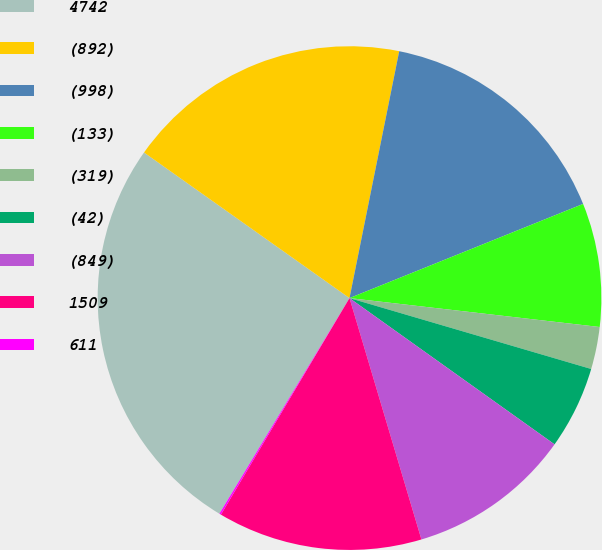Convert chart. <chart><loc_0><loc_0><loc_500><loc_500><pie_chart><fcel>4742<fcel>(892)<fcel>(998)<fcel>(133)<fcel>(319)<fcel>(42)<fcel>(849)<fcel>1509<fcel>611<nl><fcel>26.17%<fcel>18.35%<fcel>15.74%<fcel>7.93%<fcel>2.71%<fcel>5.32%<fcel>10.53%<fcel>13.14%<fcel>0.11%<nl></chart> 